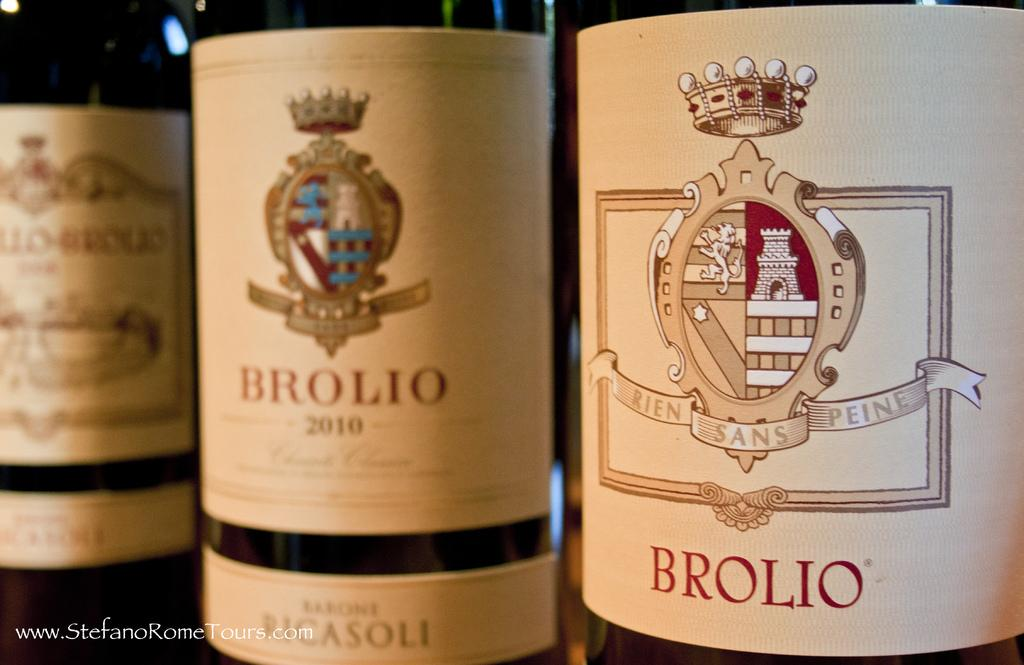<image>
Give a short and clear explanation of the subsequent image. three bottles of Brolio are sitting side by side 